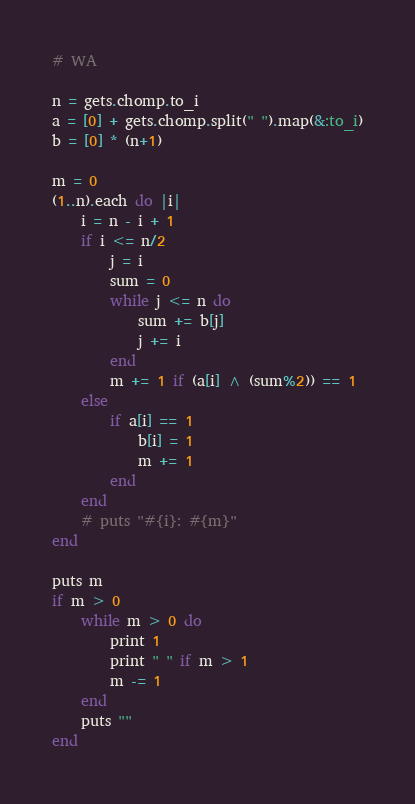Convert code to text. <code><loc_0><loc_0><loc_500><loc_500><_Ruby_># WA

n = gets.chomp.to_i
a = [0] + gets.chomp.split(" ").map(&:to_i)
b = [0] * (n+1)

m = 0
(1..n).each do |i|
    i = n - i + 1
    if i <= n/2
        j = i
        sum = 0
        while j <= n do
            sum += b[j]
            j += i
        end
        m += 1 if (a[i] ^ (sum%2)) == 1
    else
        if a[i] == 1
            b[i] = 1
            m += 1
        end
    end
    # puts "#{i}: #{m}"
end

puts m
if m > 0
    while m > 0 do
        print 1
        print " " if m > 1
        m -= 1
    end
    puts ""
end</code> 